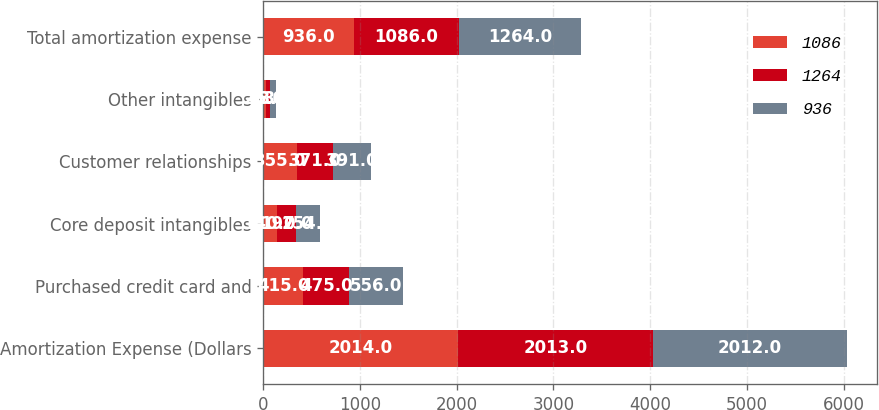<chart> <loc_0><loc_0><loc_500><loc_500><stacked_bar_chart><ecel><fcel>Amortization Expense (Dollars<fcel>Purchased credit card and<fcel>Core deposit intangibles<fcel>Customer relationships<fcel>Other intangibles<fcel>Total amortization expense<nl><fcel>1086<fcel>2014<fcel>415<fcel>140<fcel>355<fcel>26<fcel>936<nl><fcel>1264<fcel>2013<fcel>475<fcel>197<fcel>371<fcel>43<fcel>1086<nl><fcel>936<fcel>2012<fcel>556<fcel>254<fcel>391<fcel>63<fcel>1264<nl></chart> 